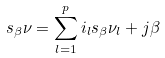<formula> <loc_0><loc_0><loc_500><loc_500>s _ { \beta } \nu = \sum _ { l = 1 } ^ { p } i _ { l } s _ { \beta } \nu _ { l } + j \beta</formula> 